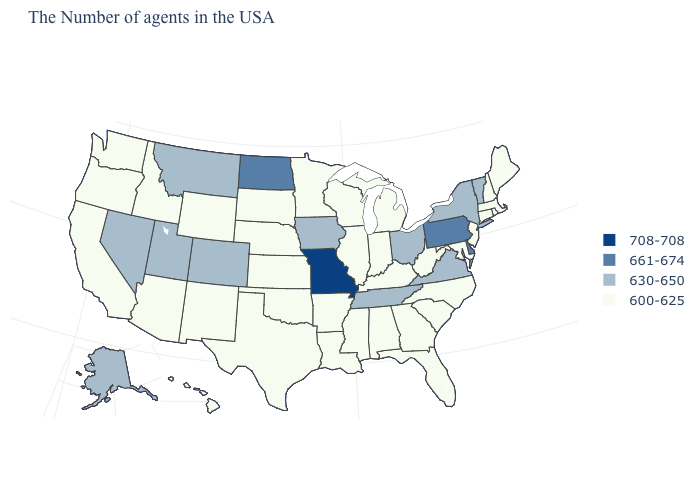Does Missouri have the highest value in the USA?
Concise answer only. Yes. How many symbols are there in the legend?
Quick response, please. 4. Name the states that have a value in the range 708-708?
Give a very brief answer. Missouri. Is the legend a continuous bar?
Give a very brief answer. No. Name the states that have a value in the range 630-650?
Concise answer only. Vermont, New York, Virginia, Ohio, Tennessee, Iowa, Colorado, Utah, Montana, Nevada, Alaska. Does Indiana have the lowest value in the USA?
Give a very brief answer. Yes. Does North Dakota have a lower value than Missouri?
Quick response, please. Yes. What is the lowest value in the Northeast?
Write a very short answer. 600-625. Does Arkansas have the highest value in the South?
Concise answer only. No. Among the states that border Pennsylvania , which have the highest value?
Short answer required. Delaware. What is the value of Hawaii?
Keep it brief. 600-625. Among the states that border Iowa , which have the lowest value?
Be succinct. Wisconsin, Illinois, Minnesota, Nebraska, South Dakota. Name the states that have a value in the range 600-625?
Write a very short answer. Maine, Massachusetts, Rhode Island, New Hampshire, Connecticut, New Jersey, Maryland, North Carolina, South Carolina, West Virginia, Florida, Georgia, Michigan, Kentucky, Indiana, Alabama, Wisconsin, Illinois, Mississippi, Louisiana, Arkansas, Minnesota, Kansas, Nebraska, Oklahoma, Texas, South Dakota, Wyoming, New Mexico, Arizona, Idaho, California, Washington, Oregon, Hawaii. Name the states that have a value in the range 661-674?
Be succinct. Delaware, Pennsylvania, North Dakota. Does Connecticut have the lowest value in the Northeast?
Answer briefly. Yes. 